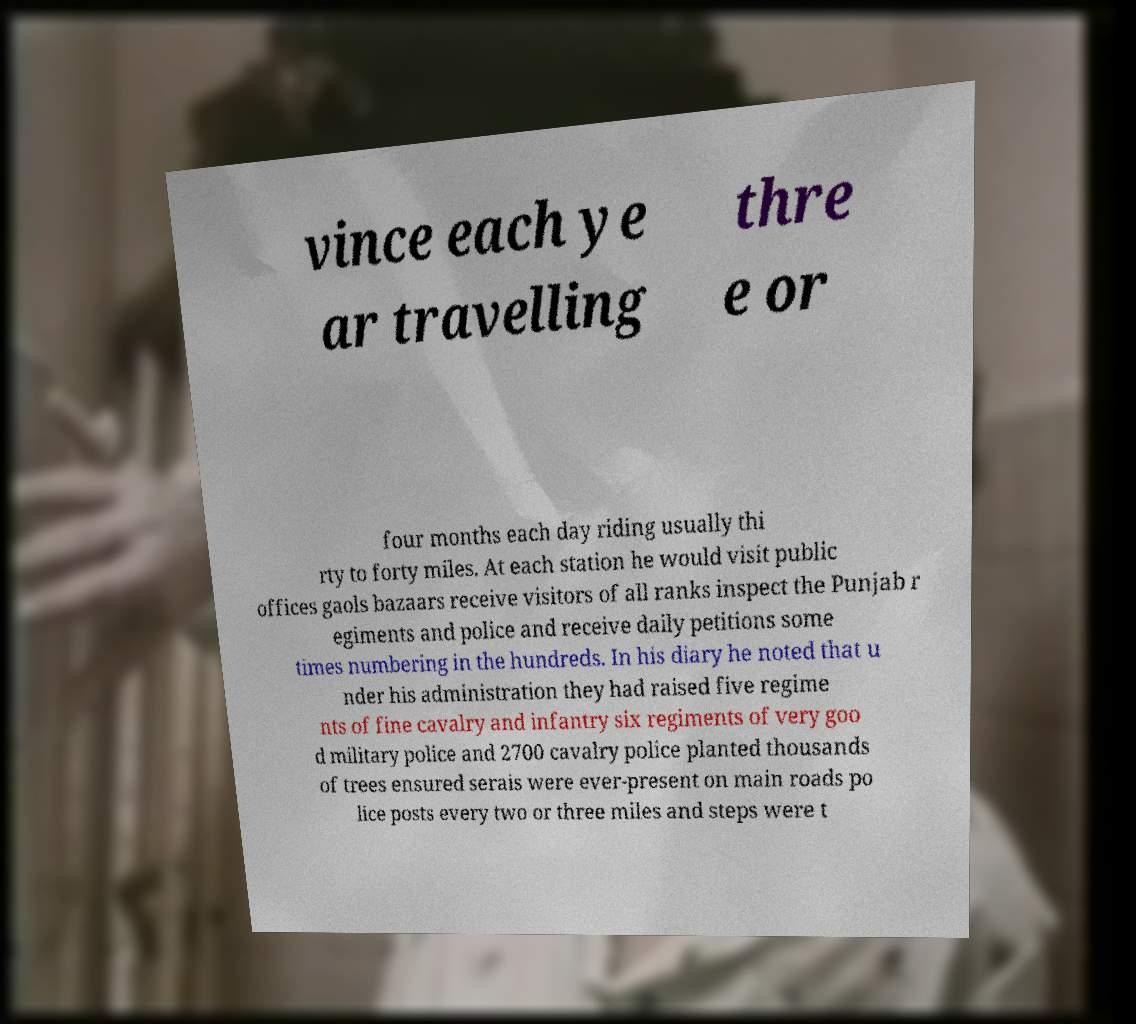I need the written content from this picture converted into text. Can you do that? vince each ye ar travelling thre e or four months each day riding usually thi rty to forty miles. At each station he would visit public offices gaols bazaars receive visitors of all ranks inspect the Punjab r egiments and police and receive daily petitions some times numbering in the hundreds. In his diary he noted that u nder his administration they had raised five regime nts of fine cavalry and infantry six regiments of very goo d military police and 2700 cavalry police planted thousands of trees ensured serais were ever-present on main roads po lice posts every two or three miles and steps were t 